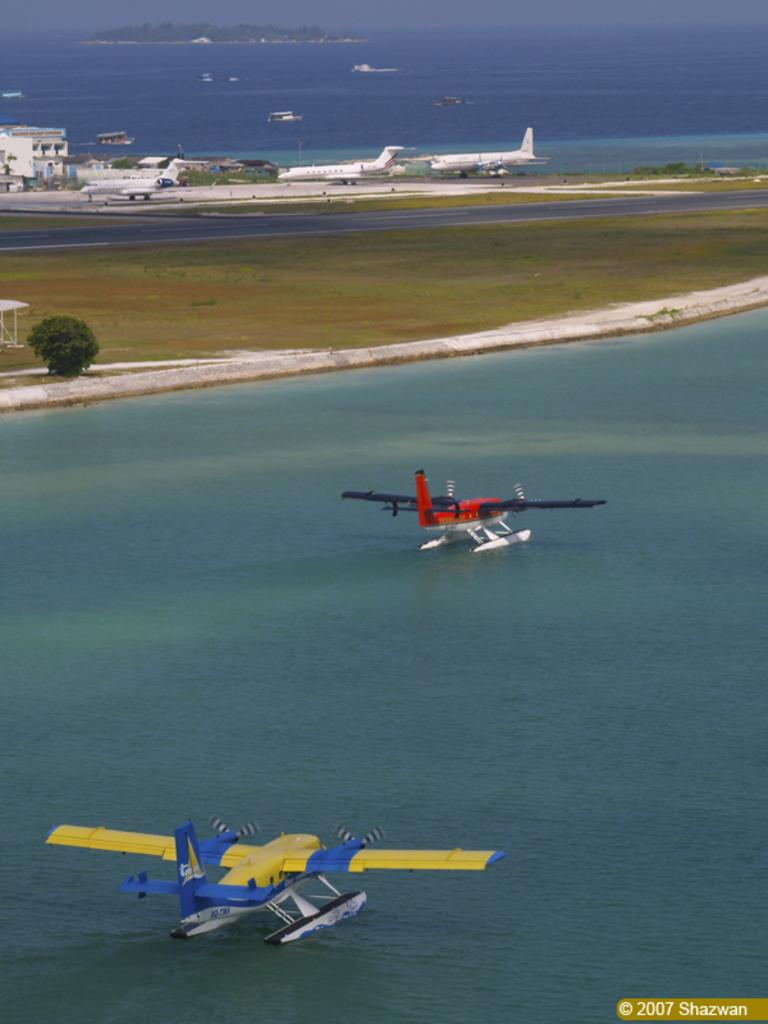How many airplanes are visible in the image? There are two airplanes in the image. Where are the airplanes located? The airplanes are on a runway. What other types of transportation can be seen in the image? There are boats on the water in the image. What natural elements are present in the image? There are trees in the image. What man-made structure is visible in the image? There is a building in the image. What type of rose is depicted on the page in the image? There is no rose or page present in the image. What type of battle is taking place in the image? There is no battle depicted in the image. 